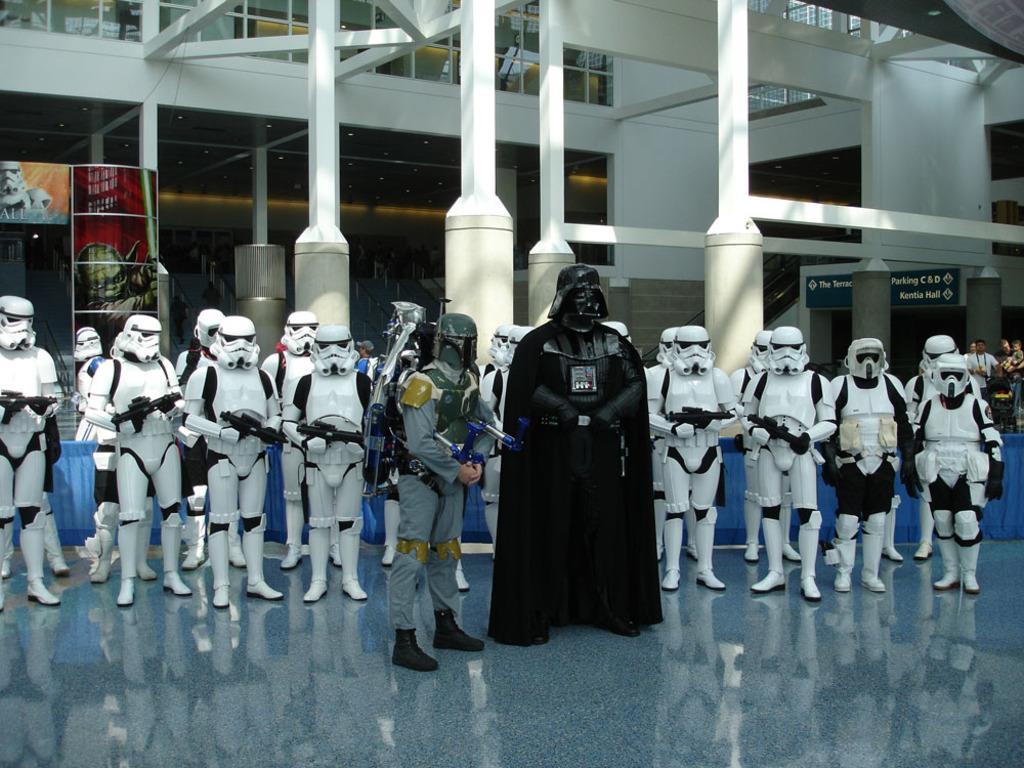Could you give a brief overview of what you see in this image? In this picture we can see few persons are standing on the floor. In the background we can see hoardings, board, pillars, glasses, ceiling, lights, and wall. 